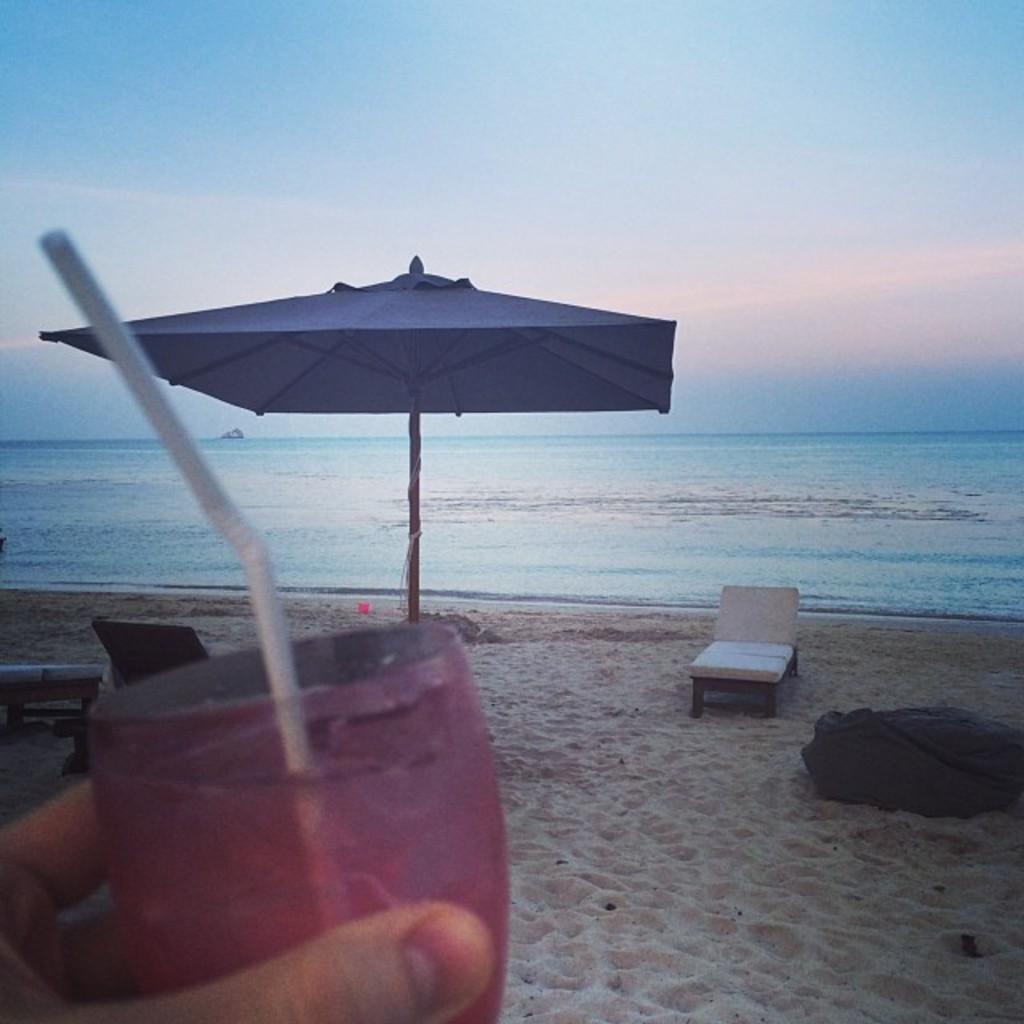Can you describe this image briefly? In this picture we can see an umbrella. This is hammock. Here we can see a glass in a hand. This is sea. On the background there is a sky. 